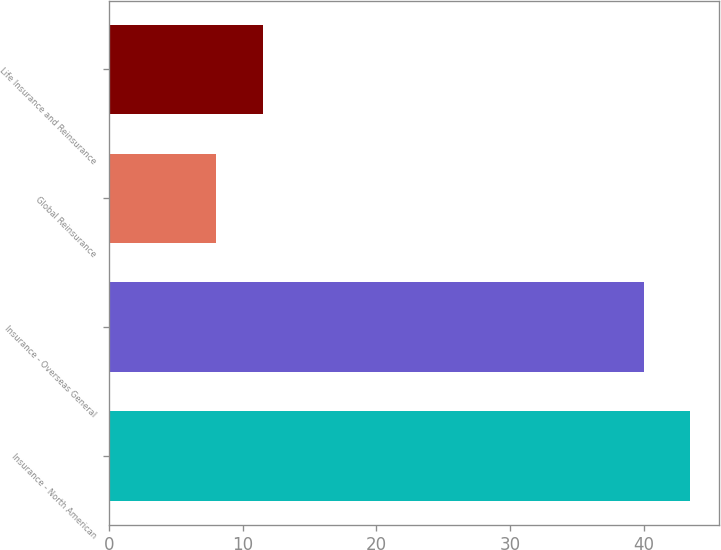<chart> <loc_0><loc_0><loc_500><loc_500><bar_chart><fcel>Insurance - North American<fcel>Insurance - Overseas General<fcel>Global Reinsurance<fcel>Life Insurance and Reinsurance<nl><fcel>43.5<fcel>40<fcel>8<fcel>11.5<nl></chart> 